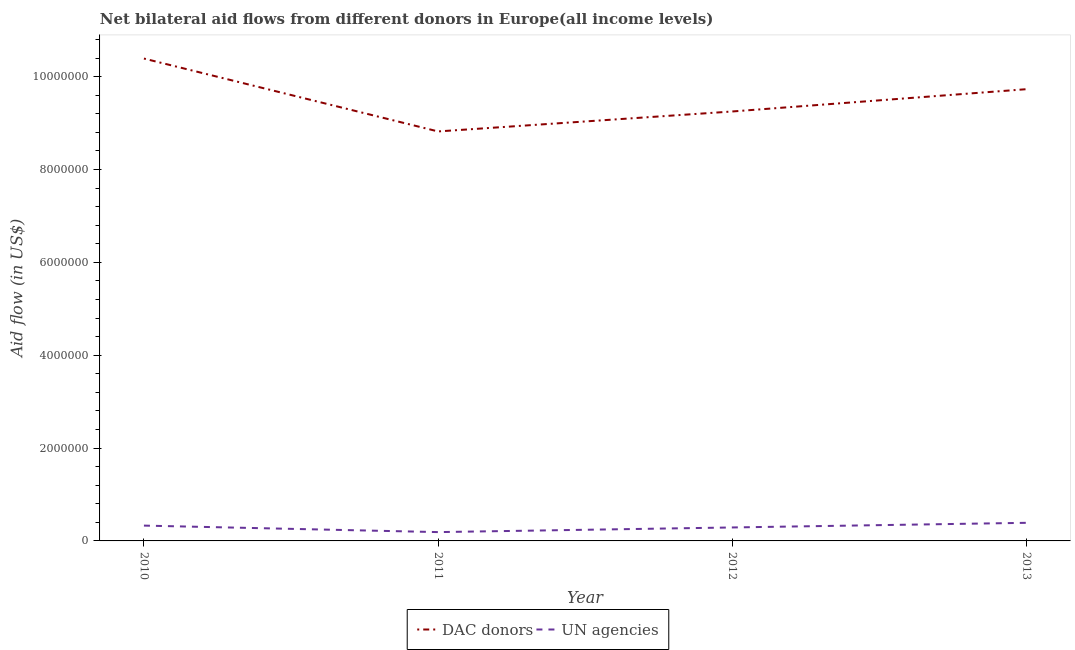How many different coloured lines are there?
Make the answer very short. 2. Does the line corresponding to aid flow from un agencies intersect with the line corresponding to aid flow from dac donors?
Your answer should be compact. No. Is the number of lines equal to the number of legend labels?
Give a very brief answer. Yes. What is the aid flow from un agencies in 2012?
Keep it short and to the point. 2.90e+05. Across all years, what is the maximum aid flow from un agencies?
Offer a very short reply. 3.90e+05. Across all years, what is the minimum aid flow from un agencies?
Your answer should be very brief. 1.90e+05. In which year was the aid flow from un agencies maximum?
Make the answer very short. 2013. In which year was the aid flow from dac donors minimum?
Your response must be concise. 2011. What is the total aid flow from un agencies in the graph?
Your answer should be very brief. 1.20e+06. What is the difference between the aid flow from dac donors in 2011 and that in 2012?
Give a very brief answer. -4.30e+05. What is the difference between the aid flow from un agencies in 2013 and the aid flow from dac donors in 2010?
Offer a very short reply. -1.00e+07. What is the average aid flow from dac donors per year?
Make the answer very short. 9.55e+06. In the year 2012, what is the difference between the aid flow from dac donors and aid flow from un agencies?
Give a very brief answer. 8.96e+06. What is the ratio of the aid flow from dac donors in 2011 to that in 2012?
Your response must be concise. 0.95. Is the difference between the aid flow from un agencies in 2012 and 2013 greater than the difference between the aid flow from dac donors in 2012 and 2013?
Give a very brief answer. Yes. What is the difference between the highest and the second highest aid flow from un agencies?
Your answer should be very brief. 6.00e+04. What is the difference between the highest and the lowest aid flow from dac donors?
Offer a terse response. 1.57e+06. How many years are there in the graph?
Provide a succinct answer. 4. Where does the legend appear in the graph?
Ensure brevity in your answer.  Bottom center. How many legend labels are there?
Your response must be concise. 2. How are the legend labels stacked?
Your answer should be very brief. Horizontal. What is the title of the graph?
Provide a succinct answer. Net bilateral aid flows from different donors in Europe(all income levels). What is the label or title of the Y-axis?
Give a very brief answer. Aid flow (in US$). What is the Aid flow (in US$) of DAC donors in 2010?
Your answer should be very brief. 1.04e+07. What is the Aid flow (in US$) of UN agencies in 2010?
Keep it short and to the point. 3.30e+05. What is the Aid flow (in US$) of DAC donors in 2011?
Provide a short and direct response. 8.82e+06. What is the Aid flow (in US$) of UN agencies in 2011?
Your answer should be compact. 1.90e+05. What is the Aid flow (in US$) in DAC donors in 2012?
Offer a terse response. 9.25e+06. What is the Aid flow (in US$) of DAC donors in 2013?
Keep it short and to the point. 9.73e+06. Across all years, what is the maximum Aid flow (in US$) in DAC donors?
Make the answer very short. 1.04e+07. Across all years, what is the maximum Aid flow (in US$) in UN agencies?
Give a very brief answer. 3.90e+05. Across all years, what is the minimum Aid flow (in US$) in DAC donors?
Ensure brevity in your answer.  8.82e+06. What is the total Aid flow (in US$) in DAC donors in the graph?
Give a very brief answer. 3.82e+07. What is the total Aid flow (in US$) in UN agencies in the graph?
Ensure brevity in your answer.  1.20e+06. What is the difference between the Aid flow (in US$) in DAC donors in 2010 and that in 2011?
Your response must be concise. 1.57e+06. What is the difference between the Aid flow (in US$) of UN agencies in 2010 and that in 2011?
Provide a succinct answer. 1.40e+05. What is the difference between the Aid flow (in US$) in DAC donors in 2010 and that in 2012?
Your response must be concise. 1.14e+06. What is the difference between the Aid flow (in US$) in DAC donors in 2010 and that in 2013?
Your answer should be compact. 6.60e+05. What is the difference between the Aid flow (in US$) of UN agencies in 2010 and that in 2013?
Provide a short and direct response. -6.00e+04. What is the difference between the Aid flow (in US$) in DAC donors in 2011 and that in 2012?
Your response must be concise. -4.30e+05. What is the difference between the Aid flow (in US$) of DAC donors in 2011 and that in 2013?
Your answer should be very brief. -9.10e+05. What is the difference between the Aid flow (in US$) in UN agencies in 2011 and that in 2013?
Give a very brief answer. -2.00e+05. What is the difference between the Aid flow (in US$) of DAC donors in 2012 and that in 2013?
Provide a short and direct response. -4.80e+05. What is the difference between the Aid flow (in US$) in UN agencies in 2012 and that in 2013?
Provide a succinct answer. -1.00e+05. What is the difference between the Aid flow (in US$) of DAC donors in 2010 and the Aid flow (in US$) of UN agencies in 2011?
Give a very brief answer. 1.02e+07. What is the difference between the Aid flow (in US$) of DAC donors in 2010 and the Aid flow (in US$) of UN agencies in 2012?
Keep it short and to the point. 1.01e+07. What is the difference between the Aid flow (in US$) in DAC donors in 2010 and the Aid flow (in US$) in UN agencies in 2013?
Provide a succinct answer. 1.00e+07. What is the difference between the Aid flow (in US$) of DAC donors in 2011 and the Aid flow (in US$) of UN agencies in 2012?
Your answer should be very brief. 8.53e+06. What is the difference between the Aid flow (in US$) in DAC donors in 2011 and the Aid flow (in US$) in UN agencies in 2013?
Provide a succinct answer. 8.43e+06. What is the difference between the Aid flow (in US$) in DAC donors in 2012 and the Aid flow (in US$) in UN agencies in 2013?
Your response must be concise. 8.86e+06. What is the average Aid flow (in US$) of DAC donors per year?
Your response must be concise. 9.55e+06. What is the average Aid flow (in US$) in UN agencies per year?
Keep it short and to the point. 3.00e+05. In the year 2010, what is the difference between the Aid flow (in US$) of DAC donors and Aid flow (in US$) of UN agencies?
Your answer should be compact. 1.01e+07. In the year 2011, what is the difference between the Aid flow (in US$) in DAC donors and Aid flow (in US$) in UN agencies?
Your answer should be compact. 8.63e+06. In the year 2012, what is the difference between the Aid flow (in US$) of DAC donors and Aid flow (in US$) of UN agencies?
Make the answer very short. 8.96e+06. In the year 2013, what is the difference between the Aid flow (in US$) of DAC donors and Aid flow (in US$) of UN agencies?
Make the answer very short. 9.34e+06. What is the ratio of the Aid flow (in US$) of DAC donors in 2010 to that in 2011?
Your answer should be very brief. 1.18. What is the ratio of the Aid flow (in US$) of UN agencies in 2010 to that in 2011?
Offer a very short reply. 1.74. What is the ratio of the Aid flow (in US$) in DAC donors in 2010 to that in 2012?
Offer a very short reply. 1.12. What is the ratio of the Aid flow (in US$) in UN agencies in 2010 to that in 2012?
Provide a short and direct response. 1.14. What is the ratio of the Aid flow (in US$) in DAC donors in 2010 to that in 2013?
Make the answer very short. 1.07. What is the ratio of the Aid flow (in US$) of UN agencies in 2010 to that in 2013?
Provide a short and direct response. 0.85. What is the ratio of the Aid flow (in US$) of DAC donors in 2011 to that in 2012?
Provide a succinct answer. 0.95. What is the ratio of the Aid flow (in US$) in UN agencies in 2011 to that in 2012?
Provide a short and direct response. 0.66. What is the ratio of the Aid flow (in US$) in DAC donors in 2011 to that in 2013?
Your answer should be compact. 0.91. What is the ratio of the Aid flow (in US$) in UN agencies in 2011 to that in 2013?
Your response must be concise. 0.49. What is the ratio of the Aid flow (in US$) in DAC donors in 2012 to that in 2013?
Provide a short and direct response. 0.95. What is the ratio of the Aid flow (in US$) of UN agencies in 2012 to that in 2013?
Ensure brevity in your answer.  0.74. What is the difference between the highest and the second highest Aid flow (in US$) of UN agencies?
Make the answer very short. 6.00e+04. What is the difference between the highest and the lowest Aid flow (in US$) of DAC donors?
Give a very brief answer. 1.57e+06. What is the difference between the highest and the lowest Aid flow (in US$) in UN agencies?
Your response must be concise. 2.00e+05. 